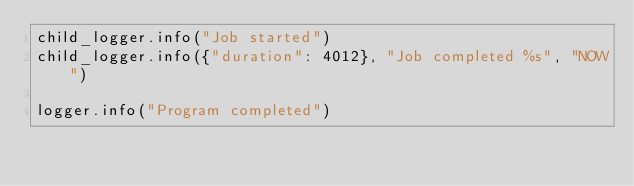<code> <loc_0><loc_0><loc_500><loc_500><_Python_>child_logger.info("Job started")
child_logger.info({"duration": 4012}, "Job completed %s", "NOW")

logger.info("Program completed")</code> 